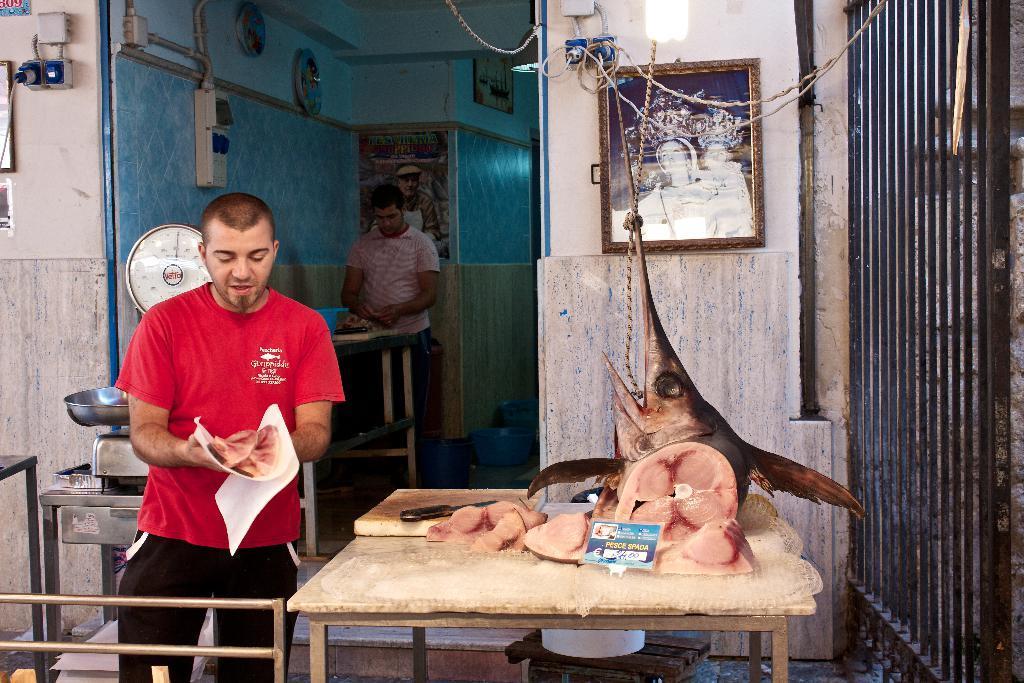Can you describe this image briefly? In this picture there is a man standing and holding a meat. There is a weighing pan. There is a meat and knife on the table. There is also other man who is standing. There is a poster on the wall. There is a frame and light. 